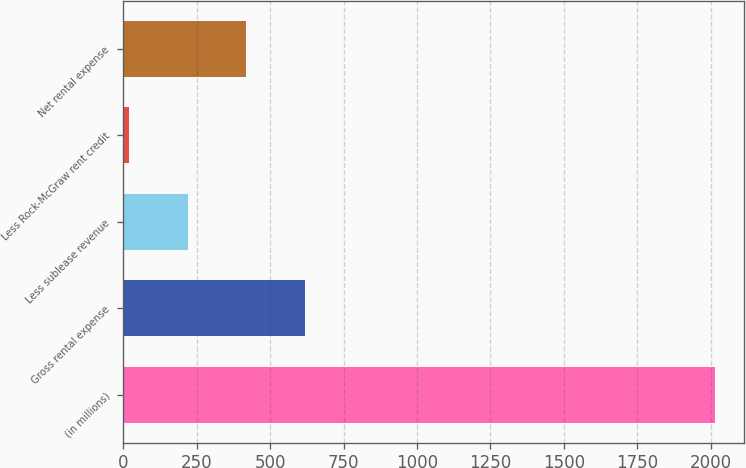<chart> <loc_0><loc_0><loc_500><loc_500><bar_chart><fcel>(in millions)<fcel>Gross rental expense<fcel>Less sublease revenue<fcel>Less Rock-McGraw rent credit<fcel>Net rental expense<nl><fcel>2013<fcel>617.9<fcel>219.3<fcel>20<fcel>418.6<nl></chart> 